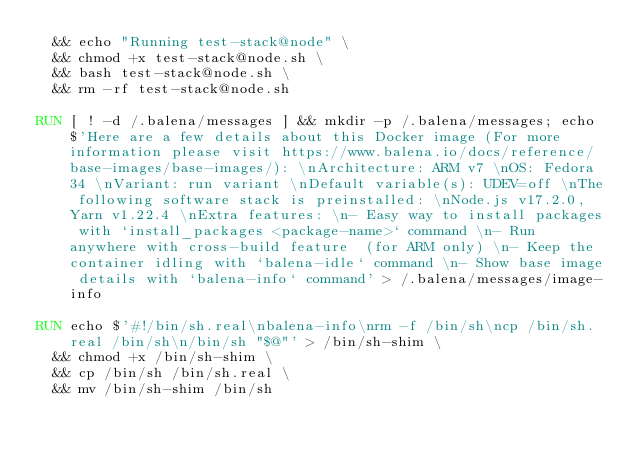<code> <loc_0><loc_0><loc_500><loc_500><_Dockerfile_>  && echo "Running test-stack@node" \
  && chmod +x test-stack@node.sh \
  && bash test-stack@node.sh \
  && rm -rf test-stack@node.sh 

RUN [ ! -d /.balena/messages ] && mkdir -p /.balena/messages; echo $'Here are a few details about this Docker image (For more information please visit https://www.balena.io/docs/reference/base-images/base-images/): \nArchitecture: ARM v7 \nOS: Fedora 34 \nVariant: run variant \nDefault variable(s): UDEV=off \nThe following software stack is preinstalled: \nNode.js v17.2.0, Yarn v1.22.4 \nExtra features: \n- Easy way to install packages with `install_packages <package-name>` command \n- Run anywhere with cross-build feature  (for ARM only) \n- Keep the container idling with `balena-idle` command \n- Show base image details with `balena-info` command' > /.balena/messages/image-info

RUN echo $'#!/bin/sh.real\nbalena-info\nrm -f /bin/sh\ncp /bin/sh.real /bin/sh\n/bin/sh "$@"' > /bin/sh-shim \
	&& chmod +x /bin/sh-shim \
	&& cp /bin/sh /bin/sh.real \
	&& mv /bin/sh-shim /bin/sh</code> 